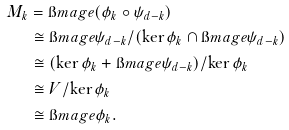<formula> <loc_0><loc_0><loc_500><loc_500>M _ { k } & = \i m a g e ( \phi _ { k } \circ \psi _ { d - k } ) \\ & \cong \i m a g e \psi _ { d - k } / ( \ker \phi _ { k } \cap \i m a g e \psi _ { d - k } ) \\ & \cong ( \ker \phi _ { k } + \i m a g e \psi _ { d - k } ) / \ker \phi _ { k } \\ & \cong V / \ker \phi _ { k } \\ & \cong \i m a g e \phi _ { k } .</formula> 